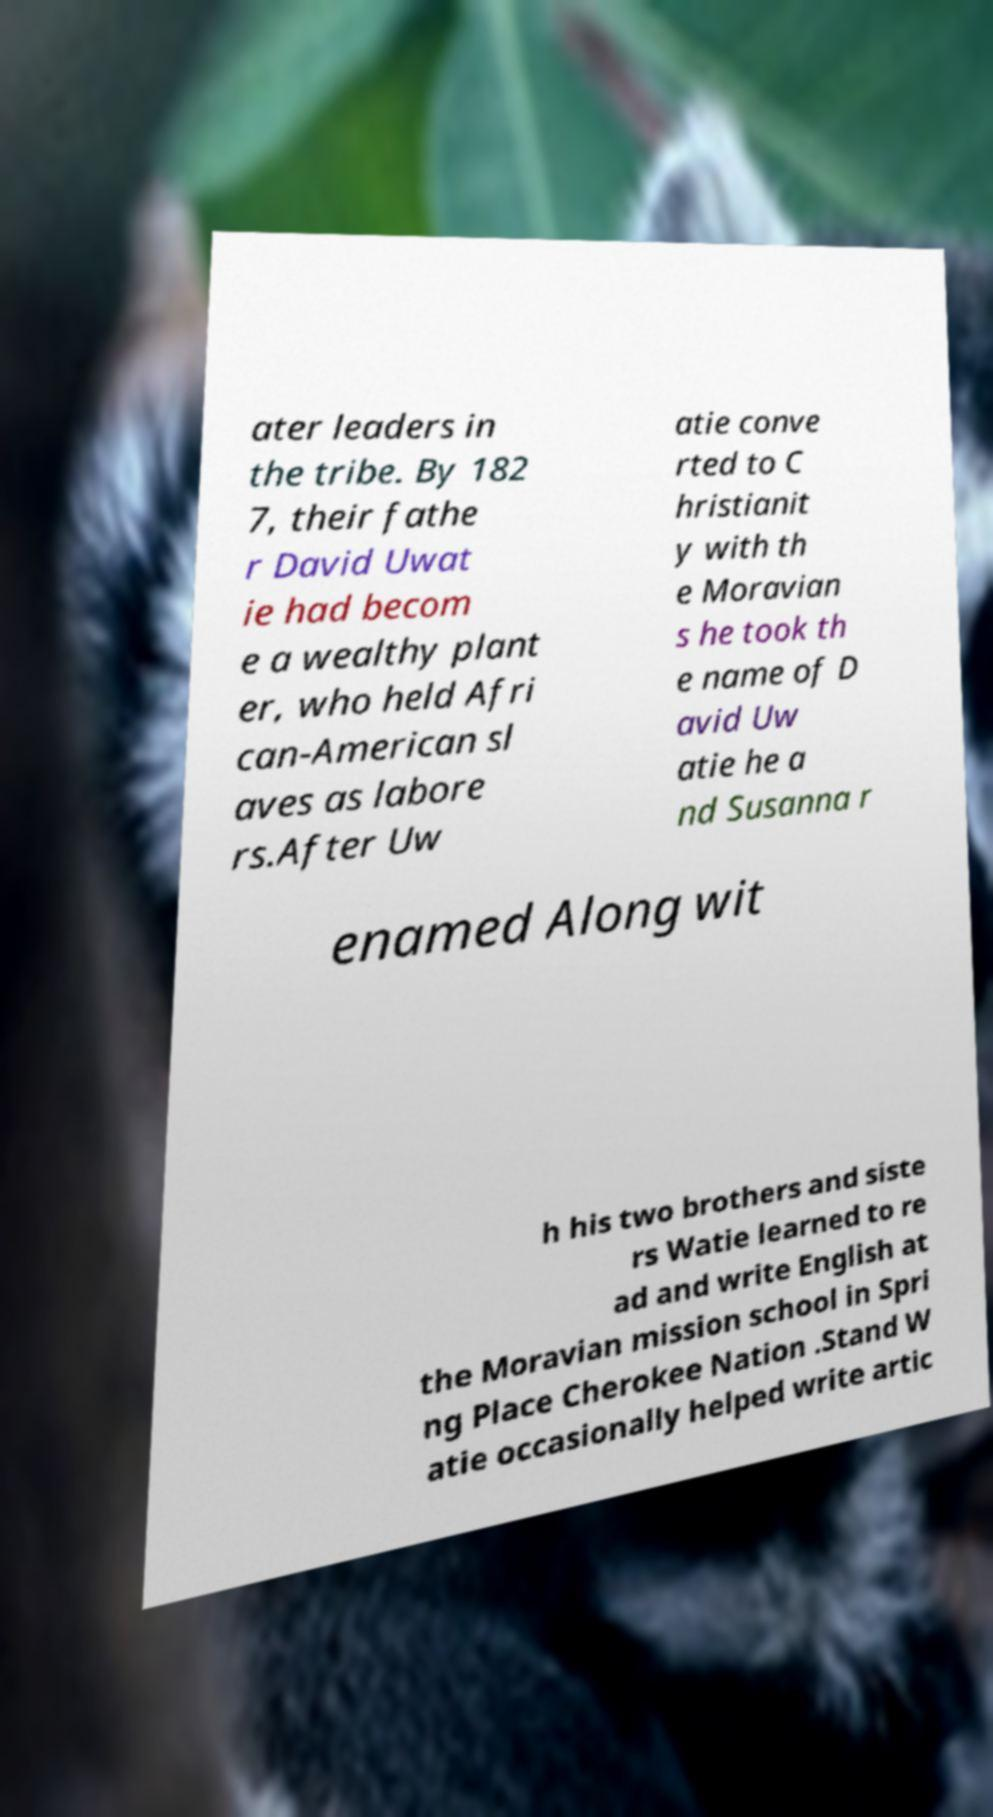What messages or text are displayed in this image? I need them in a readable, typed format. ater leaders in the tribe. By 182 7, their fathe r David Uwat ie had becom e a wealthy plant er, who held Afri can-American sl aves as labore rs.After Uw atie conve rted to C hristianit y with th e Moravian s he took th e name of D avid Uw atie he a nd Susanna r enamed Along wit h his two brothers and siste rs Watie learned to re ad and write English at the Moravian mission school in Spri ng Place Cherokee Nation .Stand W atie occasionally helped write artic 